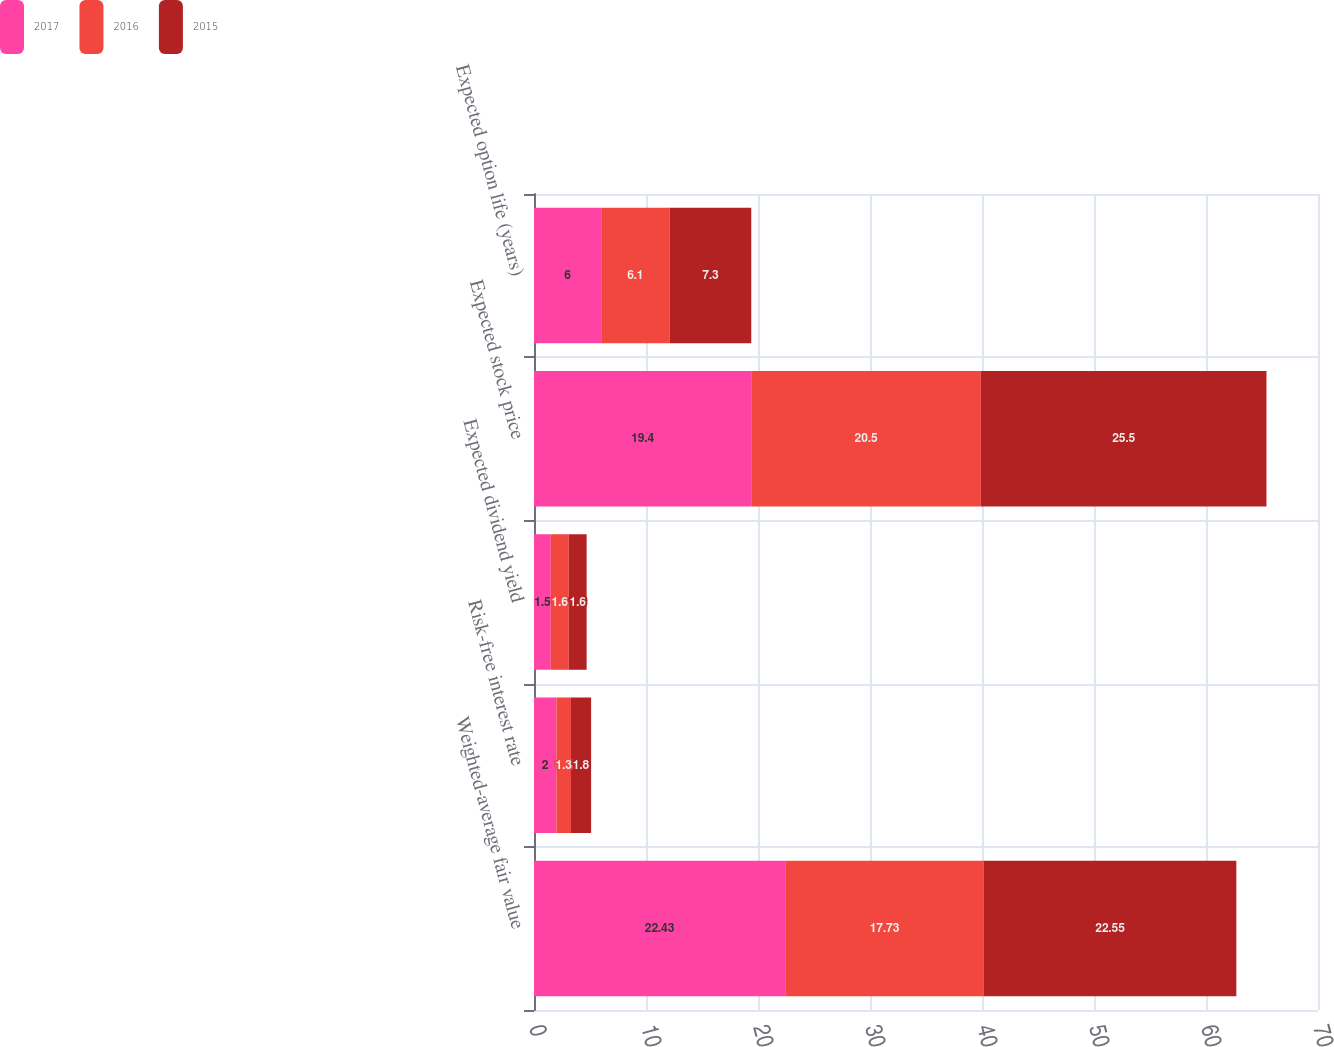Convert chart to OTSL. <chart><loc_0><loc_0><loc_500><loc_500><stacked_bar_chart><ecel><fcel>Weighted-average fair value<fcel>Risk-free interest rate<fcel>Expected dividend yield<fcel>Expected stock price<fcel>Expected option life (years)<nl><fcel>2017<fcel>22.43<fcel>2<fcel>1.5<fcel>19.4<fcel>6<nl><fcel>2016<fcel>17.73<fcel>1.3<fcel>1.6<fcel>20.5<fcel>6.1<nl><fcel>2015<fcel>22.55<fcel>1.8<fcel>1.6<fcel>25.5<fcel>7.3<nl></chart> 